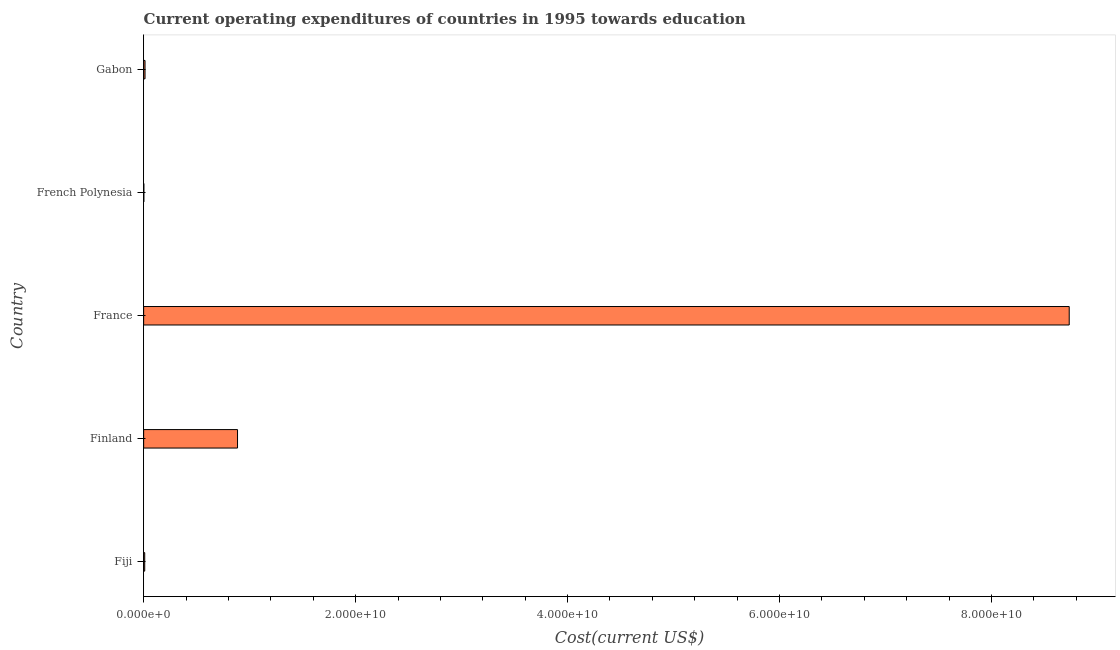Does the graph contain grids?
Your answer should be compact. No. What is the title of the graph?
Provide a short and direct response. Current operating expenditures of countries in 1995 towards education. What is the label or title of the X-axis?
Offer a terse response. Cost(current US$). What is the education expenditure in Finland?
Make the answer very short. 8.86e+09. Across all countries, what is the maximum education expenditure?
Keep it short and to the point. 8.73e+1. Across all countries, what is the minimum education expenditure?
Make the answer very short. 1.99e+07. In which country was the education expenditure maximum?
Ensure brevity in your answer.  France. In which country was the education expenditure minimum?
Give a very brief answer. French Polynesia. What is the sum of the education expenditure?
Provide a short and direct response. 9.64e+1. What is the difference between the education expenditure in France and French Polynesia?
Offer a very short reply. 8.73e+1. What is the average education expenditure per country?
Your answer should be compact. 1.93e+1. What is the median education expenditure?
Provide a short and direct response. 1.31e+08. In how many countries, is the education expenditure greater than 64000000000 US$?
Your response must be concise. 1. What is the ratio of the education expenditure in France to that in Gabon?
Your answer should be compact. 666.93. Is the difference between the education expenditure in Finland and French Polynesia greater than the difference between any two countries?
Your response must be concise. No. What is the difference between the highest and the second highest education expenditure?
Offer a very short reply. 7.85e+1. What is the difference between the highest and the lowest education expenditure?
Provide a succinct answer. 8.73e+1. In how many countries, is the education expenditure greater than the average education expenditure taken over all countries?
Offer a terse response. 1. Are all the bars in the graph horizontal?
Provide a succinct answer. Yes. What is the Cost(current US$) of Fiji?
Give a very brief answer. 1.01e+08. What is the Cost(current US$) in Finland?
Ensure brevity in your answer.  8.86e+09. What is the Cost(current US$) in France?
Your answer should be very brief. 8.73e+1. What is the Cost(current US$) in French Polynesia?
Ensure brevity in your answer.  1.99e+07. What is the Cost(current US$) of Gabon?
Offer a terse response. 1.31e+08. What is the difference between the Cost(current US$) in Fiji and Finland?
Your response must be concise. -8.76e+09. What is the difference between the Cost(current US$) in Fiji and France?
Offer a very short reply. -8.72e+1. What is the difference between the Cost(current US$) in Fiji and French Polynesia?
Your answer should be very brief. 8.09e+07. What is the difference between the Cost(current US$) in Fiji and Gabon?
Ensure brevity in your answer.  -3.01e+07. What is the difference between the Cost(current US$) in Finland and France?
Make the answer very short. -7.85e+1. What is the difference between the Cost(current US$) in Finland and French Polynesia?
Your answer should be very brief. 8.84e+09. What is the difference between the Cost(current US$) in Finland and Gabon?
Provide a short and direct response. 8.73e+09. What is the difference between the Cost(current US$) in France and French Polynesia?
Offer a terse response. 8.73e+1. What is the difference between the Cost(current US$) in France and Gabon?
Offer a very short reply. 8.72e+1. What is the difference between the Cost(current US$) in French Polynesia and Gabon?
Ensure brevity in your answer.  -1.11e+08. What is the ratio of the Cost(current US$) in Fiji to that in Finland?
Give a very brief answer. 0.01. What is the ratio of the Cost(current US$) in Fiji to that in France?
Give a very brief answer. 0. What is the ratio of the Cost(current US$) in Fiji to that in French Polynesia?
Offer a very short reply. 5.06. What is the ratio of the Cost(current US$) in Fiji to that in Gabon?
Give a very brief answer. 0.77. What is the ratio of the Cost(current US$) in Finland to that in France?
Offer a terse response. 0.1. What is the ratio of the Cost(current US$) in Finland to that in French Polynesia?
Your answer should be compact. 445.03. What is the ratio of the Cost(current US$) in Finland to that in Gabon?
Keep it short and to the point. 67.65. What is the ratio of the Cost(current US$) in France to that in French Polynesia?
Your answer should be very brief. 4387.36. What is the ratio of the Cost(current US$) in France to that in Gabon?
Ensure brevity in your answer.  666.93. What is the ratio of the Cost(current US$) in French Polynesia to that in Gabon?
Give a very brief answer. 0.15. 